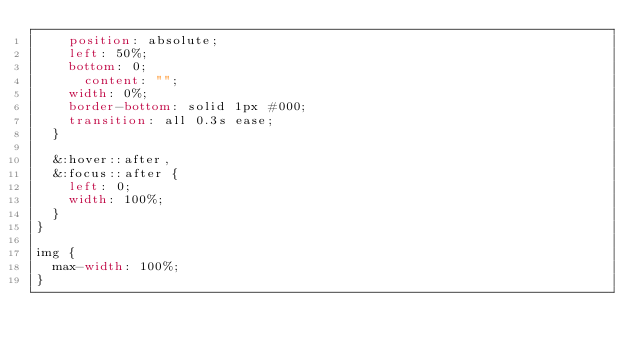Convert code to text. <code><loc_0><loc_0><loc_500><loc_500><_CSS_>		position: absolute;
		left: 50%;
		bottom: 0;
	    content: "";
		width: 0%;
		border-bottom: solid 1px #000;
		transition: all 0.3s ease;
	}

	&:hover::after,
	&:focus::after {
		left: 0;
		width: 100%;
	}
}

img {
	max-width: 100%;
}
</code> 